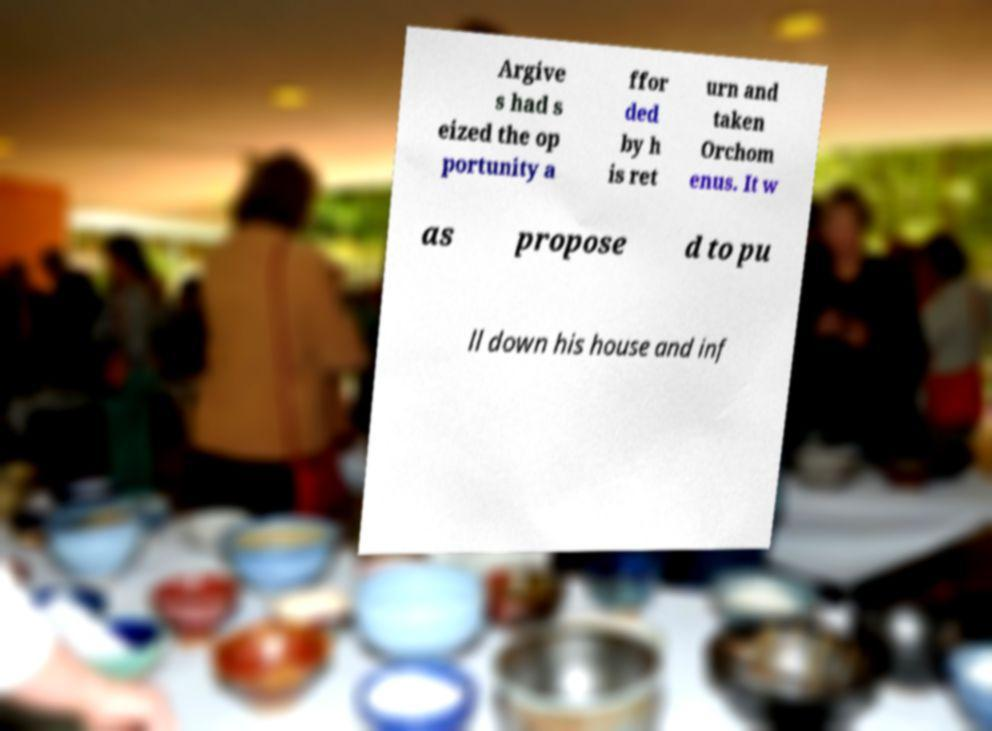Can you accurately transcribe the text from the provided image for me? Argive s had s eized the op portunity a ffor ded by h is ret urn and taken Orchom enus. It w as propose d to pu ll down his house and inf 